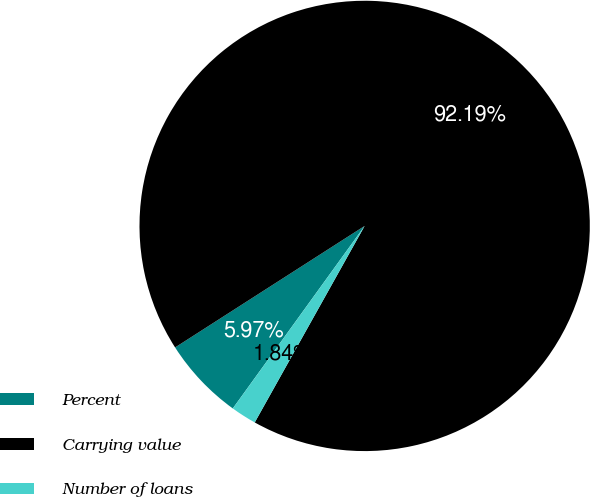<chart> <loc_0><loc_0><loc_500><loc_500><pie_chart><fcel>Percent<fcel>Carrying value<fcel>Number of loans<nl><fcel>5.97%<fcel>92.18%<fcel>1.84%<nl></chart> 